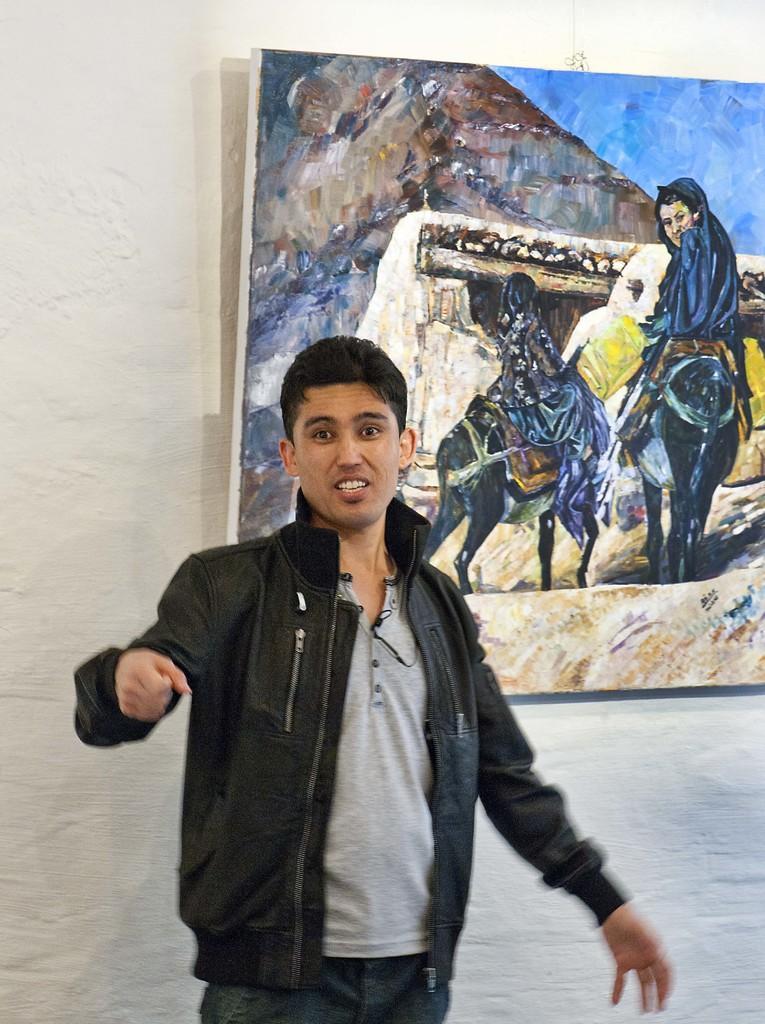Describe this image in one or two sentences. Here we can see a man. In the background there is a wall and a painting. 